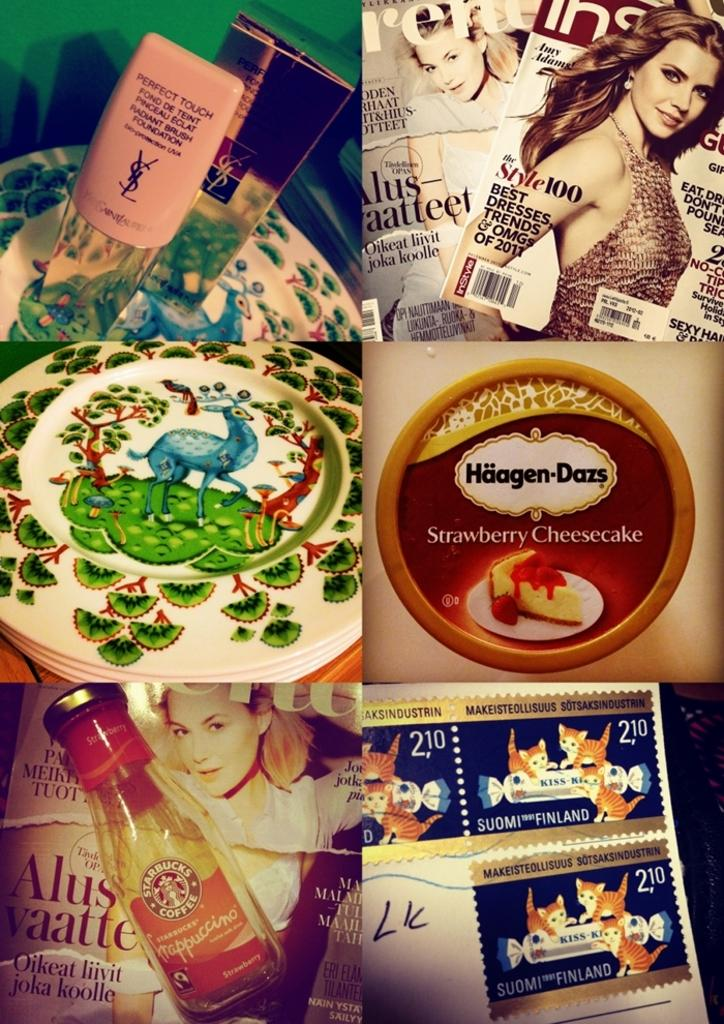<image>
Give a short and clear explanation of the subsequent image. Montage of different things with some Haagen Dazs ice cream on the middle right. 